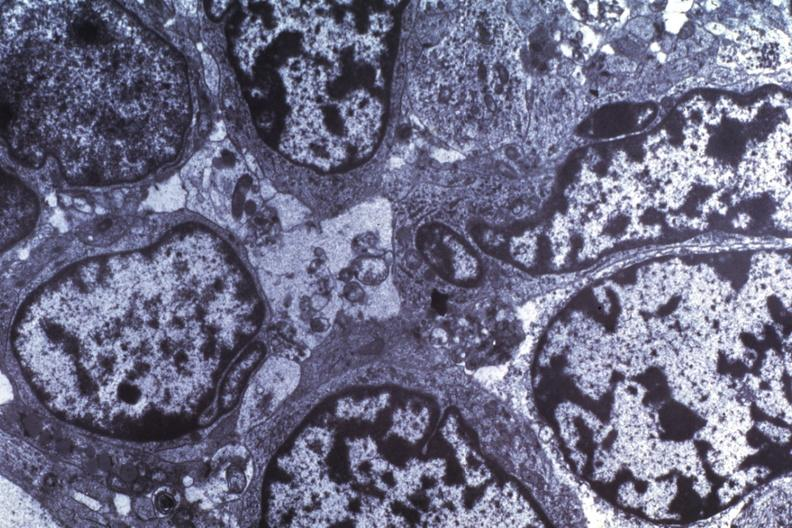s exact cause present?
Answer the question using a single word or phrase. No 